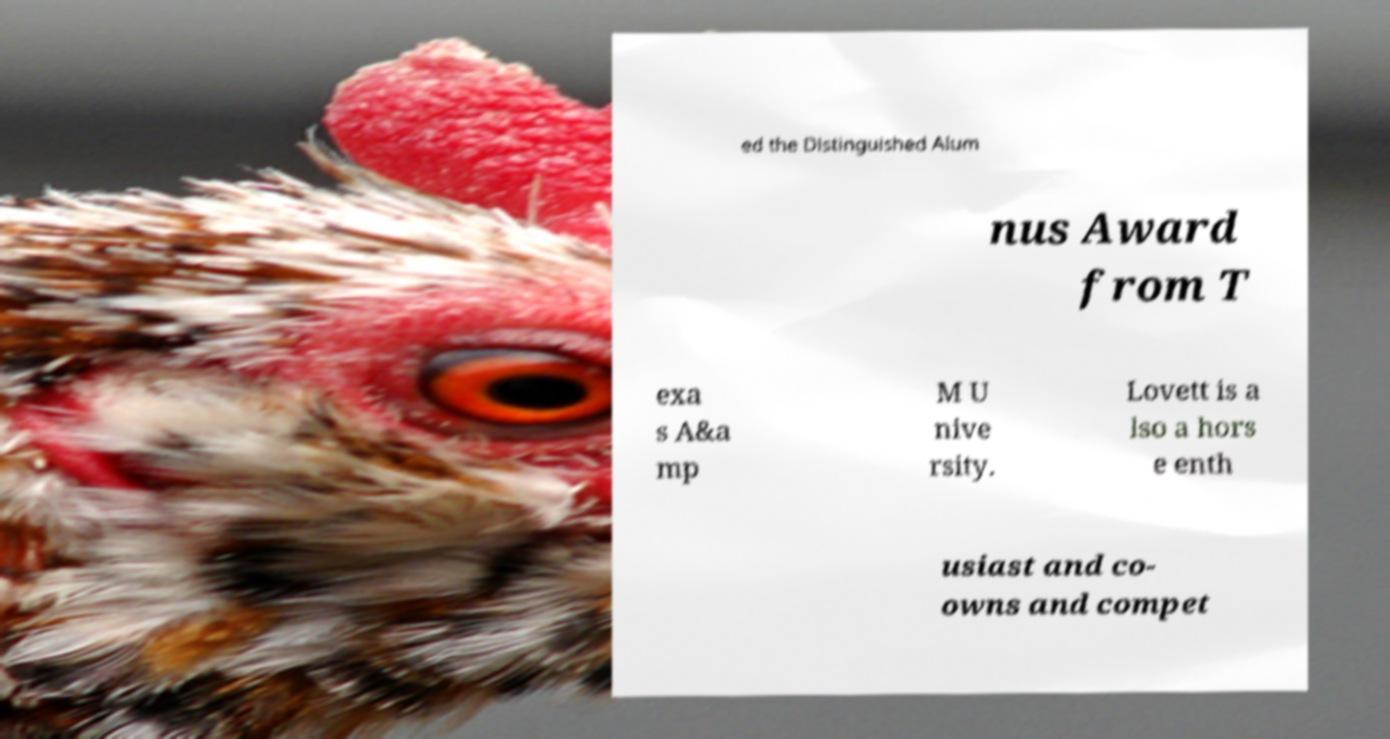For documentation purposes, I need the text within this image transcribed. Could you provide that? ed the Distinguished Alum nus Award from T exa s A&a mp M U nive rsity. Lovett is a lso a hors e enth usiast and co- owns and compet 